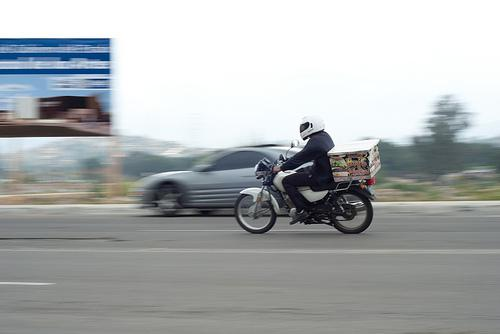Question: how many vehicles are there?
Choices:
A. 1.
B. 6.
C. 2.
D. 5.
Answer with the letter. Answer: C Question: who is riding the bike?
Choices:
A. Little girl.
B. Teenage boy.
C. A man.
D. Old man.
Answer with the letter. Answer: C Question: why is the car blurred?
Choices:
A. It's jumping.
B. It's speeding.
C. It's running.
D. Bad photographer.
Answer with the letter. Answer: B Question: what is in front of the car?
Choices:
A. Sign.
B. Building.
C. Lawn.
D. A motorcycle.
Answer with the letter. Answer: D Question: when was the picture taken?
Choices:
A. In the day.
B. Midnight.
C. Dusk.
D. Sunrise.
Answer with the letter. Answer: A Question: what is the bike's color?
Choices:
A. Blue.
B. Black.
C. White.
D. Pink.
Answer with the letter. Answer: C 